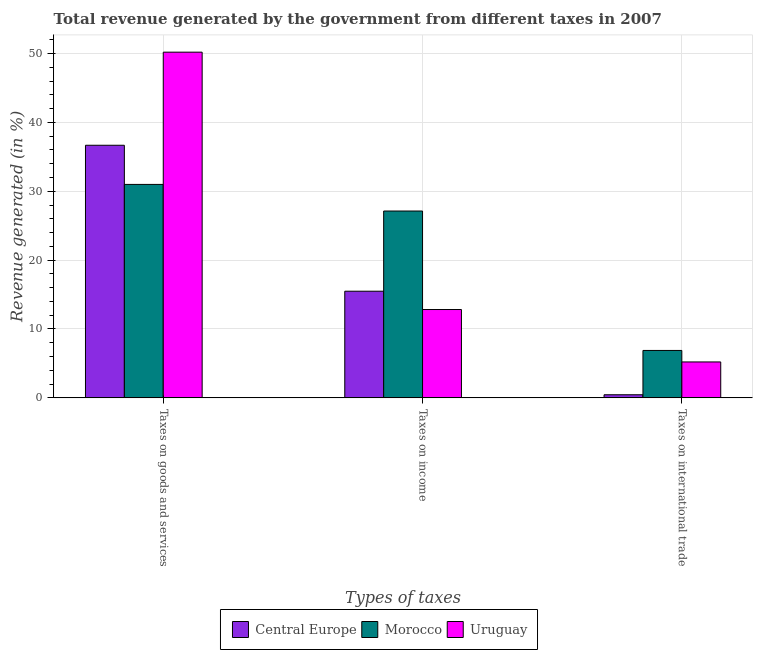Are the number of bars on each tick of the X-axis equal?
Your answer should be compact. Yes. How many bars are there on the 3rd tick from the left?
Keep it short and to the point. 3. What is the label of the 3rd group of bars from the left?
Ensure brevity in your answer.  Taxes on international trade. What is the percentage of revenue generated by tax on international trade in Central Europe?
Keep it short and to the point. 0.45. Across all countries, what is the maximum percentage of revenue generated by taxes on income?
Keep it short and to the point. 27.13. Across all countries, what is the minimum percentage of revenue generated by taxes on income?
Your answer should be very brief. 12.83. In which country was the percentage of revenue generated by tax on international trade maximum?
Keep it short and to the point. Morocco. In which country was the percentage of revenue generated by taxes on goods and services minimum?
Your answer should be compact. Morocco. What is the total percentage of revenue generated by taxes on goods and services in the graph?
Ensure brevity in your answer.  117.86. What is the difference between the percentage of revenue generated by tax on international trade in Morocco and that in Uruguay?
Your response must be concise. 1.67. What is the difference between the percentage of revenue generated by tax on international trade in Central Europe and the percentage of revenue generated by taxes on goods and services in Morocco?
Give a very brief answer. -30.54. What is the average percentage of revenue generated by taxes on income per country?
Keep it short and to the point. 18.48. What is the difference between the percentage of revenue generated by taxes on goods and services and percentage of revenue generated by taxes on income in Uruguay?
Offer a very short reply. 37.37. In how many countries, is the percentage of revenue generated by tax on international trade greater than 20 %?
Offer a terse response. 0. What is the ratio of the percentage of revenue generated by taxes on income in Uruguay to that in Central Europe?
Keep it short and to the point. 0.83. What is the difference between the highest and the second highest percentage of revenue generated by taxes on income?
Your answer should be compact. 11.64. What is the difference between the highest and the lowest percentage of revenue generated by taxes on income?
Offer a very short reply. 14.3. In how many countries, is the percentage of revenue generated by taxes on goods and services greater than the average percentage of revenue generated by taxes on goods and services taken over all countries?
Your answer should be very brief. 1. What does the 1st bar from the left in Taxes on international trade represents?
Your answer should be compact. Central Europe. What does the 3rd bar from the right in Taxes on income represents?
Keep it short and to the point. Central Europe. Is it the case that in every country, the sum of the percentage of revenue generated by taxes on goods and services and percentage of revenue generated by taxes on income is greater than the percentage of revenue generated by tax on international trade?
Your answer should be very brief. Yes. How many bars are there?
Ensure brevity in your answer.  9. Are all the bars in the graph horizontal?
Offer a terse response. No. Does the graph contain grids?
Your answer should be compact. Yes. How are the legend labels stacked?
Your answer should be very brief. Horizontal. What is the title of the graph?
Provide a short and direct response. Total revenue generated by the government from different taxes in 2007. What is the label or title of the X-axis?
Make the answer very short. Types of taxes. What is the label or title of the Y-axis?
Give a very brief answer. Revenue generated (in %). What is the Revenue generated (in %) in Central Europe in Taxes on goods and services?
Offer a very short reply. 36.67. What is the Revenue generated (in %) in Morocco in Taxes on goods and services?
Keep it short and to the point. 30.99. What is the Revenue generated (in %) of Uruguay in Taxes on goods and services?
Give a very brief answer. 50.19. What is the Revenue generated (in %) in Central Europe in Taxes on income?
Give a very brief answer. 15.49. What is the Revenue generated (in %) of Morocco in Taxes on income?
Your answer should be very brief. 27.13. What is the Revenue generated (in %) in Uruguay in Taxes on income?
Ensure brevity in your answer.  12.83. What is the Revenue generated (in %) in Central Europe in Taxes on international trade?
Offer a very short reply. 0.45. What is the Revenue generated (in %) in Morocco in Taxes on international trade?
Offer a very short reply. 6.89. What is the Revenue generated (in %) in Uruguay in Taxes on international trade?
Your response must be concise. 5.22. Across all Types of taxes, what is the maximum Revenue generated (in %) in Central Europe?
Your response must be concise. 36.67. Across all Types of taxes, what is the maximum Revenue generated (in %) in Morocco?
Offer a very short reply. 30.99. Across all Types of taxes, what is the maximum Revenue generated (in %) in Uruguay?
Keep it short and to the point. 50.19. Across all Types of taxes, what is the minimum Revenue generated (in %) of Central Europe?
Offer a very short reply. 0.45. Across all Types of taxes, what is the minimum Revenue generated (in %) in Morocco?
Offer a terse response. 6.89. Across all Types of taxes, what is the minimum Revenue generated (in %) in Uruguay?
Offer a very short reply. 5.22. What is the total Revenue generated (in %) of Central Europe in the graph?
Make the answer very short. 52.61. What is the total Revenue generated (in %) in Morocco in the graph?
Ensure brevity in your answer.  65. What is the total Revenue generated (in %) of Uruguay in the graph?
Your answer should be very brief. 68.24. What is the difference between the Revenue generated (in %) of Central Europe in Taxes on goods and services and that in Taxes on income?
Provide a succinct answer. 21.19. What is the difference between the Revenue generated (in %) of Morocco in Taxes on goods and services and that in Taxes on income?
Offer a terse response. 3.86. What is the difference between the Revenue generated (in %) of Uruguay in Taxes on goods and services and that in Taxes on income?
Make the answer very short. 37.37. What is the difference between the Revenue generated (in %) in Central Europe in Taxes on goods and services and that in Taxes on international trade?
Your answer should be compact. 36.22. What is the difference between the Revenue generated (in %) of Morocco in Taxes on goods and services and that in Taxes on international trade?
Your answer should be compact. 24.1. What is the difference between the Revenue generated (in %) of Uruguay in Taxes on goods and services and that in Taxes on international trade?
Keep it short and to the point. 44.98. What is the difference between the Revenue generated (in %) of Central Europe in Taxes on income and that in Taxes on international trade?
Keep it short and to the point. 15.03. What is the difference between the Revenue generated (in %) in Morocco in Taxes on income and that in Taxes on international trade?
Provide a succinct answer. 20.24. What is the difference between the Revenue generated (in %) in Uruguay in Taxes on income and that in Taxes on international trade?
Your answer should be compact. 7.61. What is the difference between the Revenue generated (in %) of Central Europe in Taxes on goods and services and the Revenue generated (in %) of Morocco in Taxes on income?
Give a very brief answer. 9.55. What is the difference between the Revenue generated (in %) of Central Europe in Taxes on goods and services and the Revenue generated (in %) of Uruguay in Taxes on income?
Give a very brief answer. 23.85. What is the difference between the Revenue generated (in %) of Morocco in Taxes on goods and services and the Revenue generated (in %) of Uruguay in Taxes on income?
Your answer should be very brief. 18.16. What is the difference between the Revenue generated (in %) of Central Europe in Taxes on goods and services and the Revenue generated (in %) of Morocco in Taxes on international trade?
Provide a short and direct response. 29.79. What is the difference between the Revenue generated (in %) of Central Europe in Taxes on goods and services and the Revenue generated (in %) of Uruguay in Taxes on international trade?
Offer a very short reply. 31.46. What is the difference between the Revenue generated (in %) of Morocco in Taxes on goods and services and the Revenue generated (in %) of Uruguay in Taxes on international trade?
Provide a short and direct response. 25.77. What is the difference between the Revenue generated (in %) in Central Europe in Taxes on income and the Revenue generated (in %) in Morocco in Taxes on international trade?
Your answer should be very brief. 8.6. What is the difference between the Revenue generated (in %) of Central Europe in Taxes on income and the Revenue generated (in %) of Uruguay in Taxes on international trade?
Make the answer very short. 10.27. What is the difference between the Revenue generated (in %) in Morocco in Taxes on income and the Revenue generated (in %) in Uruguay in Taxes on international trade?
Provide a short and direct response. 21.91. What is the average Revenue generated (in %) of Central Europe per Types of taxes?
Keep it short and to the point. 17.54. What is the average Revenue generated (in %) in Morocco per Types of taxes?
Provide a short and direct response. 21.67. What is the average Revenue generated (in %) of Uruguay per Types of taxes?
Provide a succinct answer. 22.75. What is the difference between the Revenue generated (in %) in Central Europe and Revenue generated (in %) in Morocco in Taxes on goods and services?
Your answer should be compact. 5.68. What is the difference between the Revenue generated (in %) in Central Europe and Revenue generated (in %) in Uruguay in Taxes on goods and services?
Provide a succinct answer. -13.52. What is the difference between the Revenue generated (in %) in Morocco and Revenue generated (in %) in Uruguay in Taxes on goods and services?
Provide a short and direct response. -19.2. What is the difference between the Revenue generated (in %) of Central Europe and Revenue generated (in %) of Morocco in Taxes on income?
Offer a very short reply. -11.64. What is the difference between the Revenue generated (in %) in Central Europe and Revenue generated (in %) in Uruguay in Taxes on income?
Give a very brief answer. 2.66. What is the difference between the Revenue generated (in %) of Morocco and Revenue generated (in %) of Uruguay in Taxes on income?
Offer a terse response. 14.3. What is the difference between the Revenue generated (in %) of Central Europe and Revenue generated (in %) of Morocco in Taxes on international trade?
Offer a very short reply. -6.43. What is the difference between the Revenue generated (in %) of Central Europe and Revenue generated (in %) of Uruguay in Taxes on international trade?
Offer a very short reply. -4.76. What is the difference between the Revenue generated (in %) of Morocco and Revenue generated (in %) of Uruguay in Taxes on international trade?
Provide a short and direct response. 1.67. What is the ratio of the Revenue generated (in %) in Central Europe in Taxes on goods and services to that in Taxes on income?
Make the answer very short. 2.37. What is the ratio of the Revenue generated (in %) in Morocco in Taxes on goods and services to that in Taxes on income?
Give a very brief answer. 1.14. What is the ratio of the Revenue generated (in %) in Uruguay in Taxes on goods and services to that in Taxes on income?
Keep it short and to the point. 3.91. What is the ratio of the Revenue generated (in %) of Central Europe in Taxes on goods and services to that in Taxes on international trade?
Give a very brief answer. 81.14. What is the ratio of the Revenue generated (in %) of Morocco in Taxes on goods and services to that in Taxes on international trade?
Your answer should be compact. 4.5. What is the ratio of the Revenue generated (in %) in Uruguay in Taxes on goods and services to that in Taxes on international trade?
Give a very brief answer. 9.62. What is the ratio of the Revenue generated (in %) of Central Europe in Taxes on income to that in Taxes on international trade?
Offer a very short reply. 34.26. What is the ratio of the Revenue generated (in %) in Morocco in Taxes on income to that in Taxes on international trade?
Offer a terse response. 3.94. What is the ratio of the Revenue generated (in %) in Uruguay in Taxes on income to that in Taxes on international trade?
Provide a succinct answer. 2.46. What is the difference between the highest and the second highest Revenue generated (in %) of Central Europe?
Your response must be concise. 21.19. What is the difference between the highest and the second highest Revenue generated (in %) in Morocco?
Provide a succinct answer. 3.86. What is the difference between the highest and the second highest Revenue generated (in %) of Uruguay?
Keep it short and to the point. 37.37. What is the difference between the highest and the lowest Revenue generated (in %) in Central Europe?
Provide a succinct answer. 36.22. What is the difference between the highest and the lowest Revenue generated (in %) in Morocco?
Make the answer very short. 24.1. What is the difference between the highest and the lowest Revenue generated (in %) in Uruguay?
Offer a terse response. 44.98. 